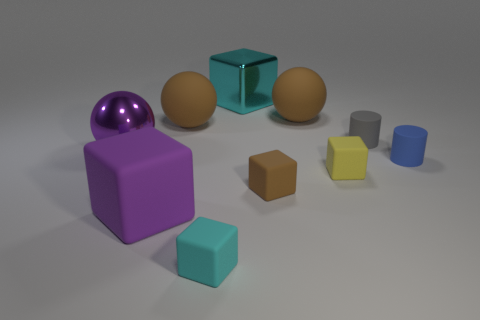There is a purple object in front of the blue object; is its shape the same as the thing on the left side of the purple matte block?
Your answer should be very brief. No. How many objects are cyan blocks behind the tiny blue rubber cylinder or large cubes right of the big purple rubber block?
Your answer should be compact. 1. What number of other things are the same material as the tiny yellow object?
Keep it short and to the point. 7. Do the big thing that is in front of the brown rubber block and the gray thing have the same material?
Keep it short and to the point. Yes. Is the number of tiny matte things that are on the left side of the brown rubber block greater than the number of matte cubes that are behind the cyan metal block?
Provide a short and direct response. Yes. What number of things are big balls left of the yellow cube or big green metallic cubes?
Provide a short and direct response. 3. What is the shape of the small brown thing that is made of the same material as the small yellow thing?
Your answer should be very brief. Cube. Is there anything else that has the same shape as the tiny cyan matte thing?
Offer a terse response. Yes. What is the color of the big rubber object that is both on the left side of the small brown cube and behind the purple ball?
Give a very brief answer. Brown. How many cylinders are tiny gray rubber things or big cyan shiny things?
Provide a short and direct response. 1. 